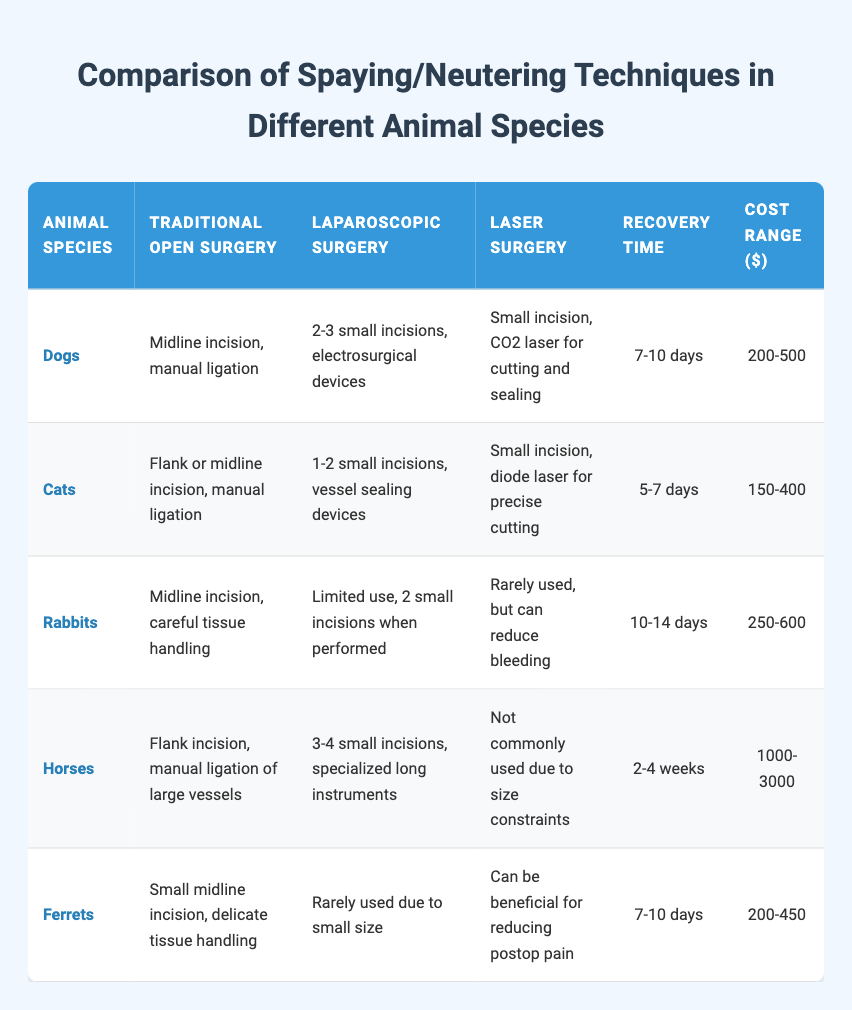What is the recovery time for cats? The recovery time for cats is listed in the "Recovery Time" column of the table, where it shows that it takes 5-7 days for cats to recover after spaying/neutering.
Answer: 5-7 days Which animal species has the highest cost range for surgery? Looking at the "Cost Range ($)" column, horses have the highest cost range listed at 1000-3000 dollars, which can be directly observed from the table.
Answer: 1000-3000 How many small incisions are typically made for dogs undergoing laparoscopic surgery? In the "Laparoscopic Surgery" column for dogs, it states that 2-3 small incisions are made, which can be easily found in the table for the dog row.
Answer: 2-3 small incisions If a rabbit undergoes traditional open surgery, how long is their recovery time compared to cats? The recovery time for rabbits is 10-14 days and for cats, it is 5-7 days. Thus, the recovery time for rabbits is longer by at least 3 days when comparing the minimum recovery times (10-7=3) or 7 days when comparing maximum recovery times (14-7=7).
Answer: Rabbits have a longer recovery time by 3 to 7 days Is laser surgery commonly used for horses? According to the table, it states that laser surgery is not commonly used for horses due to size constraints, which addresses the query directly.
Answer: No What is the average recovery time for all the animals listed? The recovery times are as follows: Dogs (7-10 days), Cats (5-7 days), Rabbits (10-14 days), Horses (14-28 days), and Ferrets (7-10 days). To find the average, convert ranges to their midpoints: Dogs (8.5), Cats (6), Rabbits (12), Horses (21), and Ferrets (8.5). Then sum the midpoints (8.5 + 6 + 12 + 21 + 8.5 = 56) and divide by the count (5): 56/5 = 11.2 days on average.
Answer: 11.2 days How many species have a recovery time of 7-10 days? Looking at the table, both dogs and ferrets have a recovery time listed as 7-10 days; thus, there are two species with this recovery time.
Answer: 2 species 